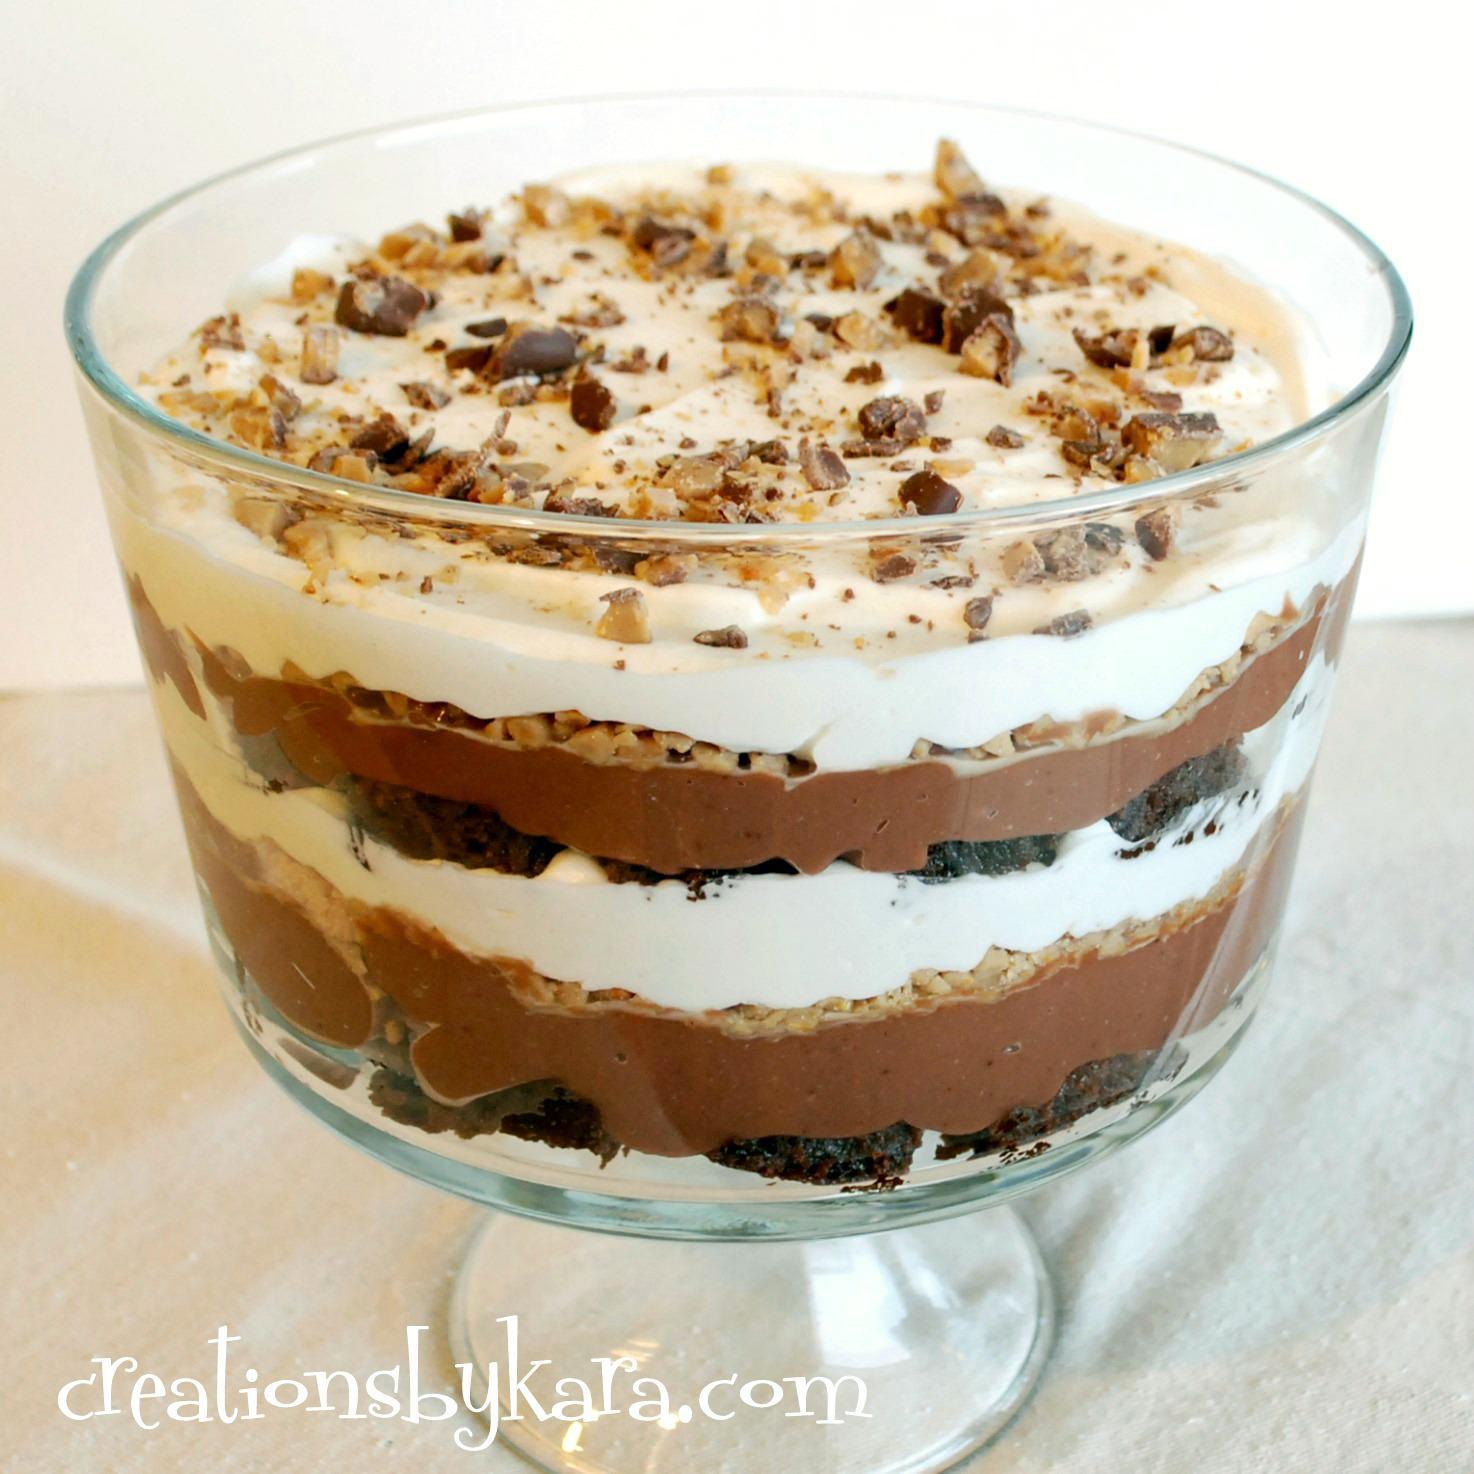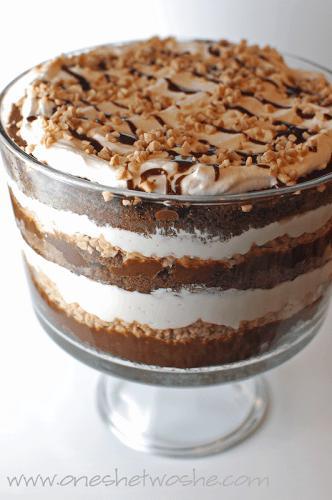The first image is the image on the left, the second image is the image on the right. Examine the images to the left and right. Is the description "Both of the trifles are in glass dishes with stands." accurate? Answer yes or no. Yes. 